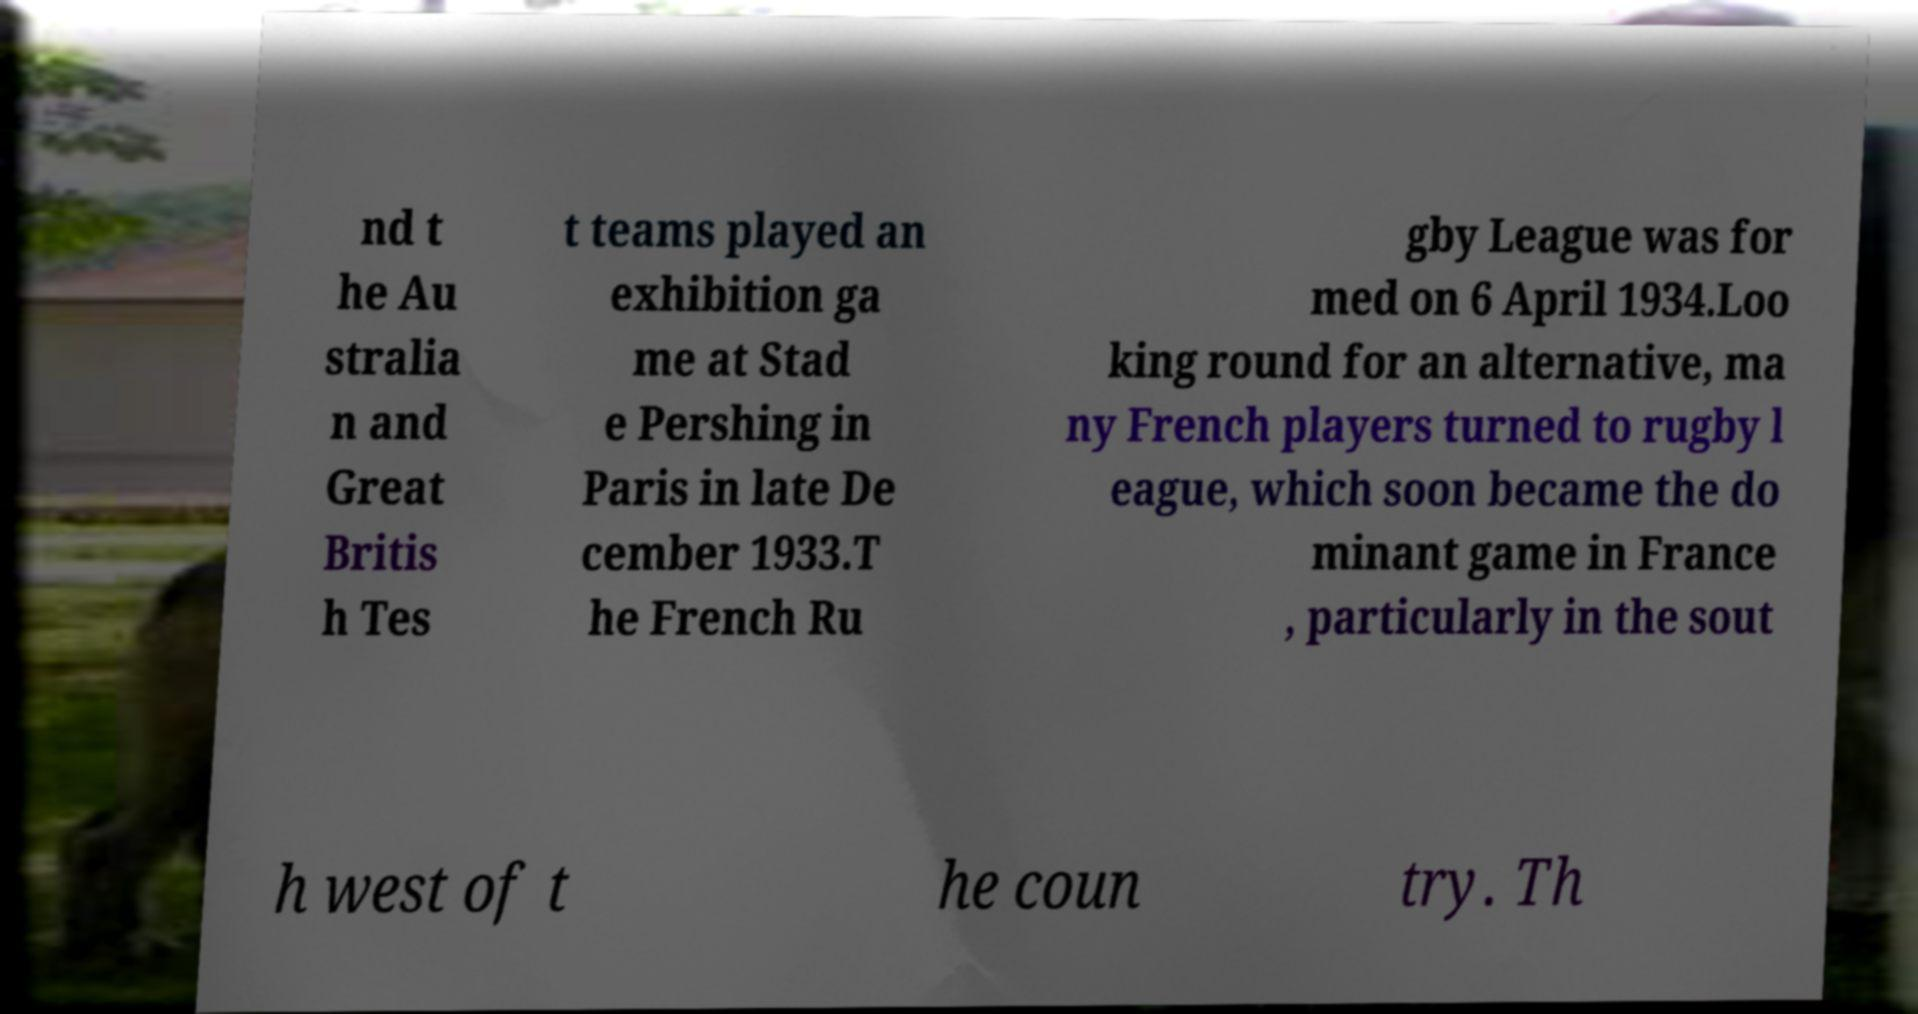I need the written content from this picture converted into text. Can you do that? nd t he Au stralia n and Great Britis h Tes t teams played an exhibition ga me at Stad e Pershing in Paris in late De cember 1933.T he French Ru gby League was for med on 6 April 1934.Loo king round for an alternative, ma ny French players turned to rugby l eague, which soon became the do minant game in France , particularly in the sout h west of t he coun try. Th 